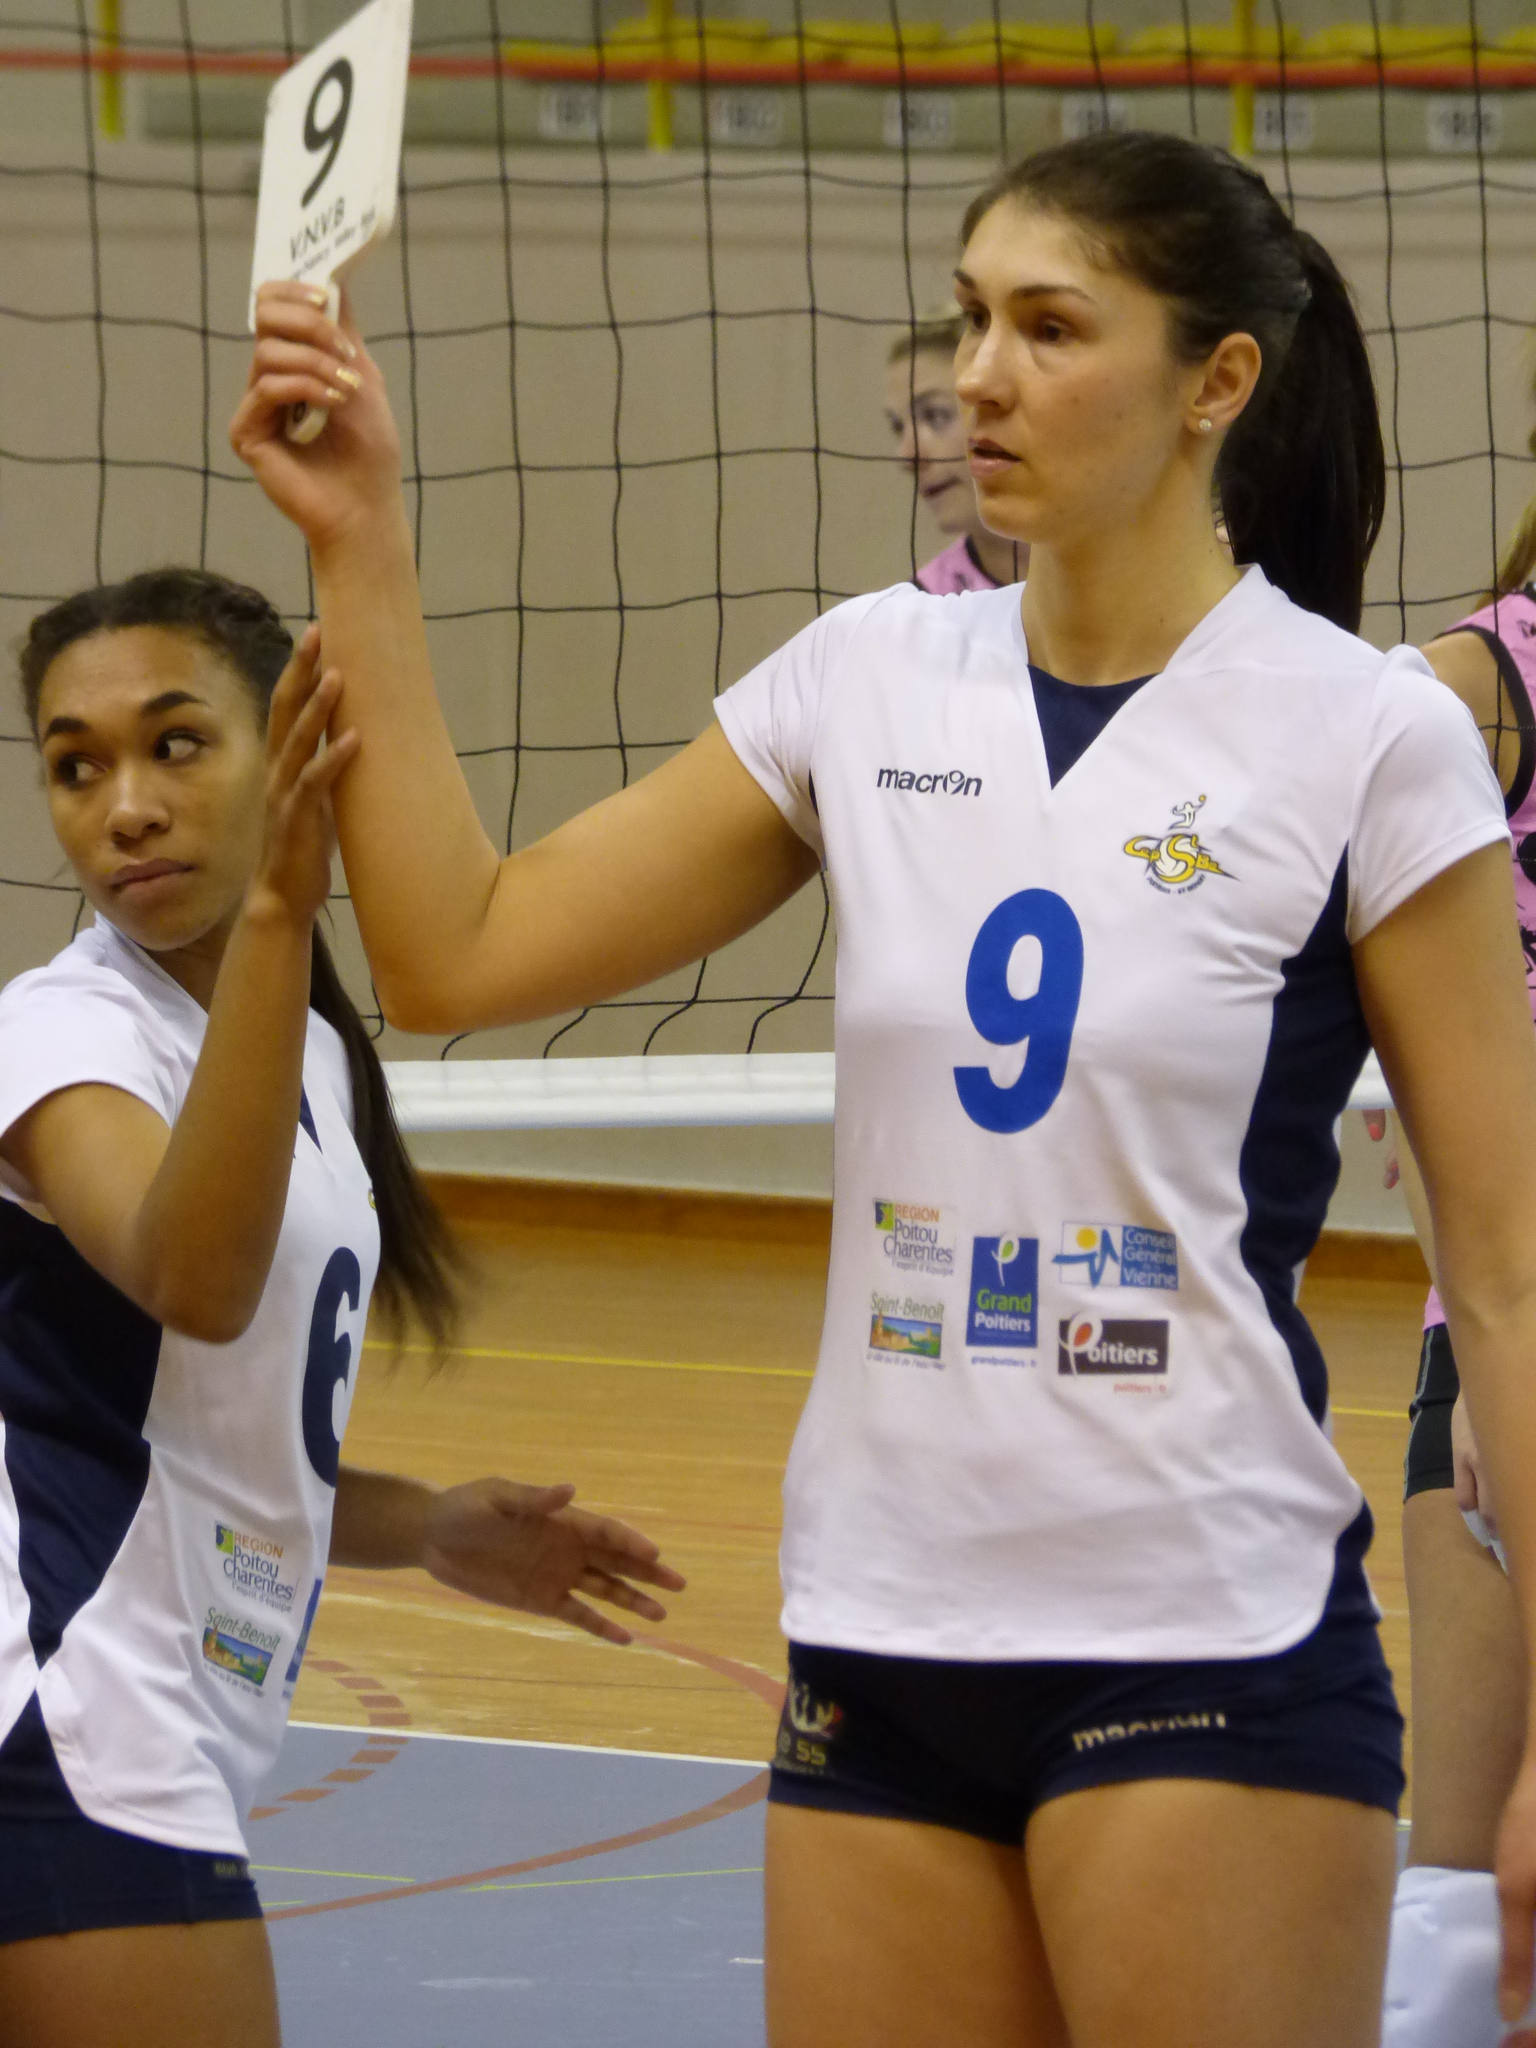<image>
Give a short and clear explanation of the subsequent image. Player number 9 holds up a card that also has the number 9 on it. 